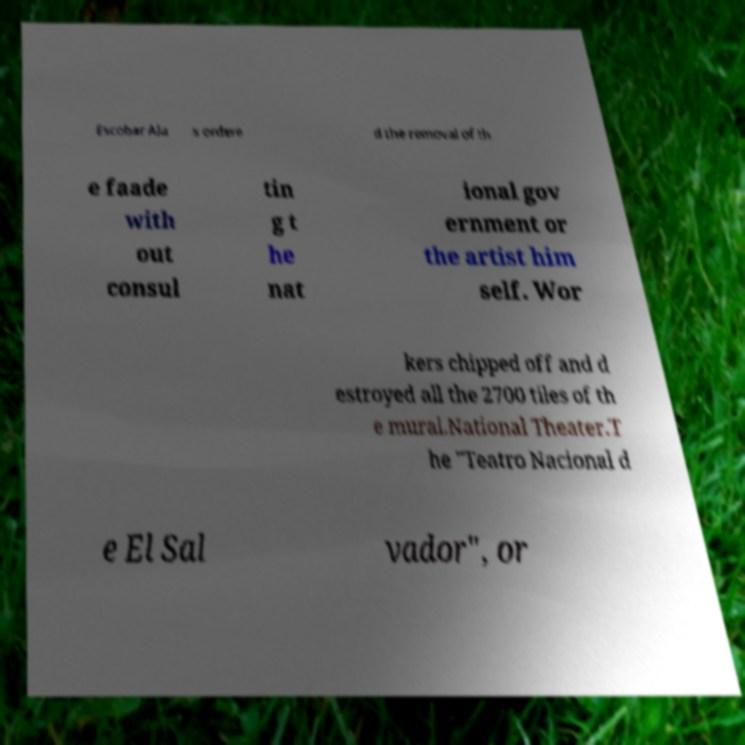Please identify and transcribe the text found in this image. Escobar Ala s ordere d the removal of th e faade with out consul tin g t he nat ional gov ernment or the artist him self. Wor kers chipped off and d estroyed all the 2700 tiles of th e mural.National Theater.T he "Teatro Nacional d e El Sal vador", or 